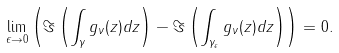<formula> <loc_0><loc_0><loc_500><loc_500>\lim _ { \epsilon \rightarrow 0 } \left ( \Im \left ( \int _ { \gamma } g _ { \nu } ( z ) d z \right ) - \Im \left ( \int _ { \gamma _ { \epsilon } } g _ { \nu } ( z ) d z \right ) \right ) = 0 .</formula> 